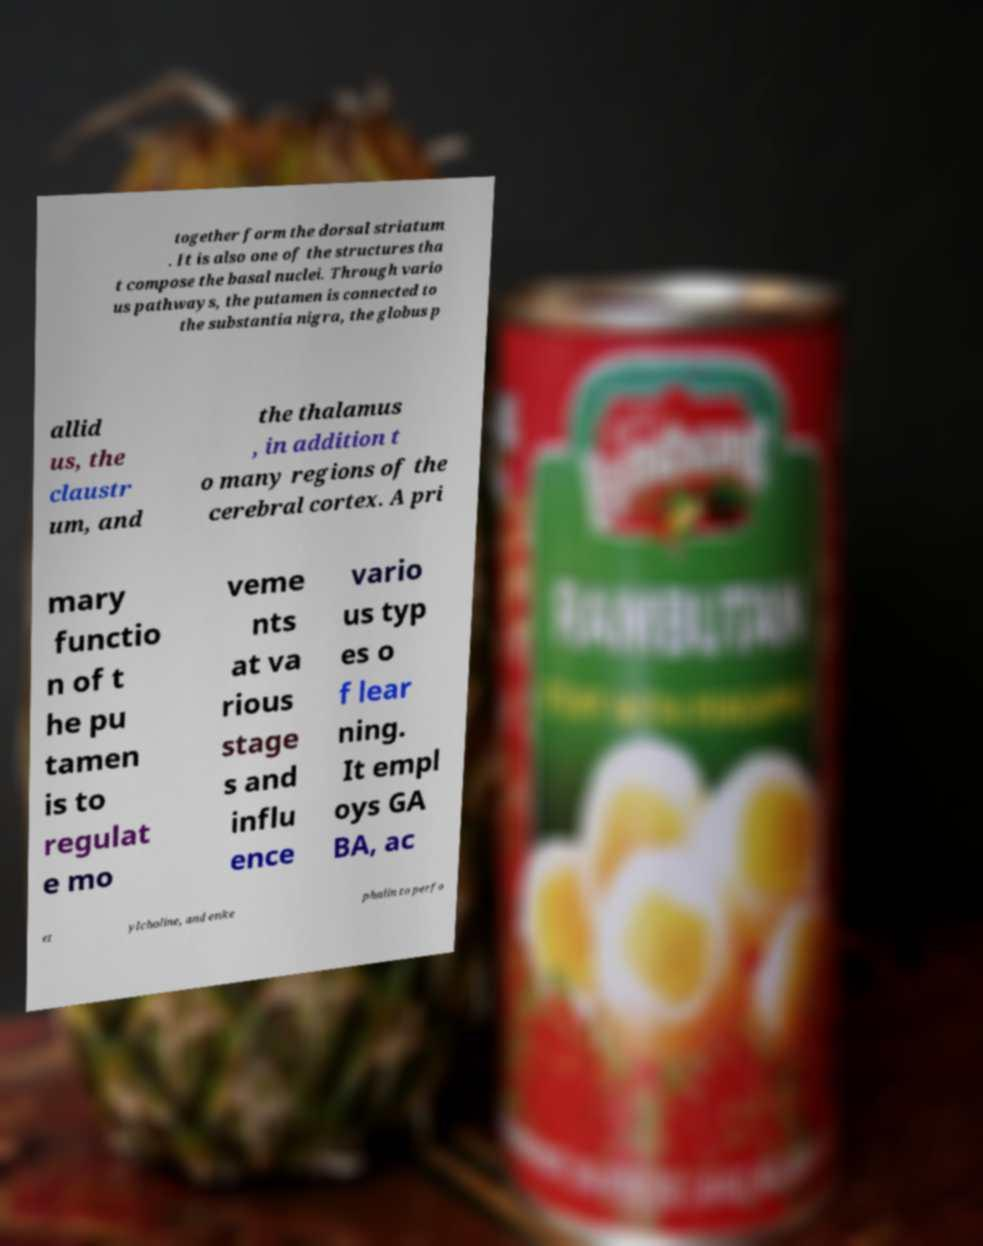Please identify and transcribe the text found in this image. together form the dorsal striatum . It is also one of the structures tha t compose the basal nuclei. Through vario us pathways, the putamen is connected to the substantia nigra, the globus p allid us, the claustr um, and the thalamus , in addition t o many regions of the cerebral cortex. A pri mary functio n of t he pu tamen is to regulat e mo veme nts at va rious stage s and influ ence vario us typ es o f lear ning. It empl oys GA BA, ac et ylcholine, and enke phalin to perfo 